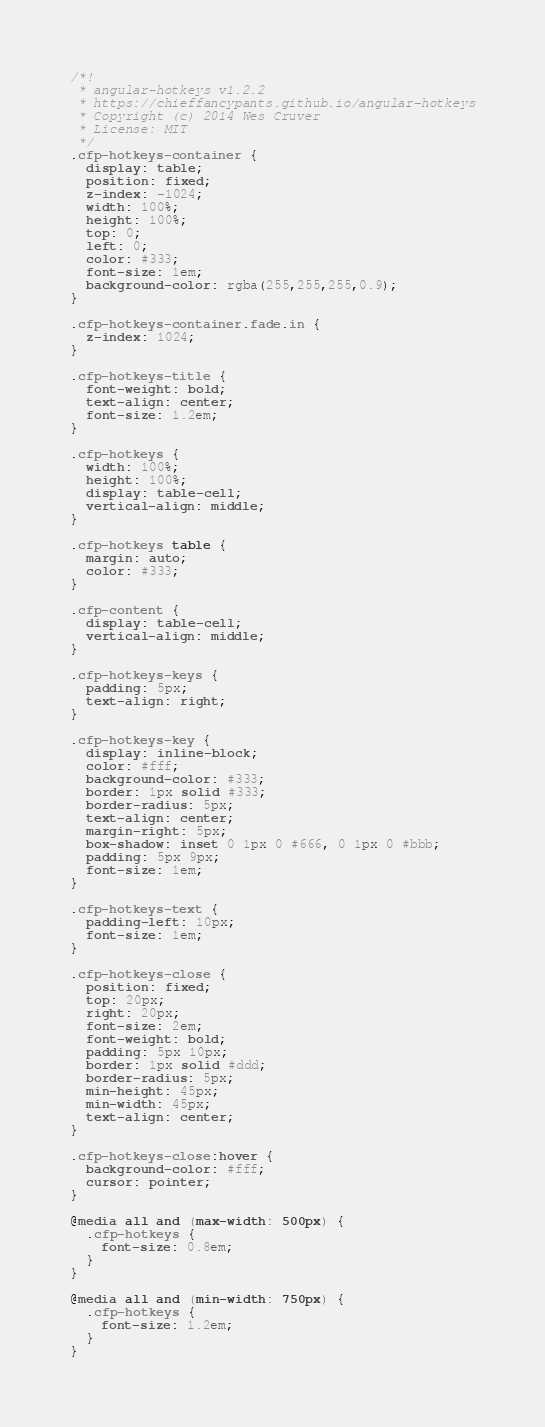<code> <loc_0><loc_0><loc_500><loc_500><_CSS_>/*! 
 * angular-hotkeys v1.2.2
 * https://chieffancypants.github.io/angular-hotkeys
 * Copyright (c) 2014 Wes Cruver
 * License: MIT
 */
.cfp-hotkeys-container {
  display: table;
  position: fixed;
  z-index: -1024;
  width: 100%;
  height: 100%;
  top: 0;
  left: 0;
  color: #333;
  font-size: 1em;
  background-color: rgba(255,255,255,0.9);
}

.cfp-hotkeys-container.fade.in {
  z-index: 1024;
}

.cfp-hotkeys-title {
  font-weight: bold;
  text-align: center;
  font-size: 1.2em;
}

.cfp-hotkeys {
  width: 100%;
  height: 100%;
  display: table-cell;
  vertical-align: middle;
}

.cfp-hotkeys table {
  margin: auto;
  color: #333;
}

.cfp-content {
  display: table-cell;
  vertical-align: middle;
}

.cfp-hotkeys-keys {
  padding: 5px;
  text-align: right;
}

.cfp-hotkeys-key {
  display: inline-block;
  color: #fff;
  background-color: #333;
  border: 1px solid #333;
  border-radius: 5px;
  text-align: center;
  margin-right: 5px;
  box-shadow: inset 0 1px 0 #666, 0 1px 0 #bbb;
  padding: 5px 9px;
  font-size: 1em;
}

.cfp-hotkeys-text {
  padding-left: 10px;
  font-size: 1em;
}

.cfp-hotkeys-close {
  position: fixed;
  top: 20px;
  right: 20px;
  font-size: 2em;
  font-weight: bold;
  padding: 5px 10px;
  border: 1px solid #ddd;
  border-radius: 5px;
  min-height: 45px;
  min-width: 45px;
  text-align: center;
}

.cfp-hotkeys-close:hover {
  background-color: #fff;
  cursor: pointer;
}

@media all and (max-width: 500px) {
  .cfp-hotkeys {
    font-size: 0.8em;
  }
}

@media all and (min-width: 750px) {
  .cfp-hotkeys {
    font-size: 1.2em;
  }
}
</code> 